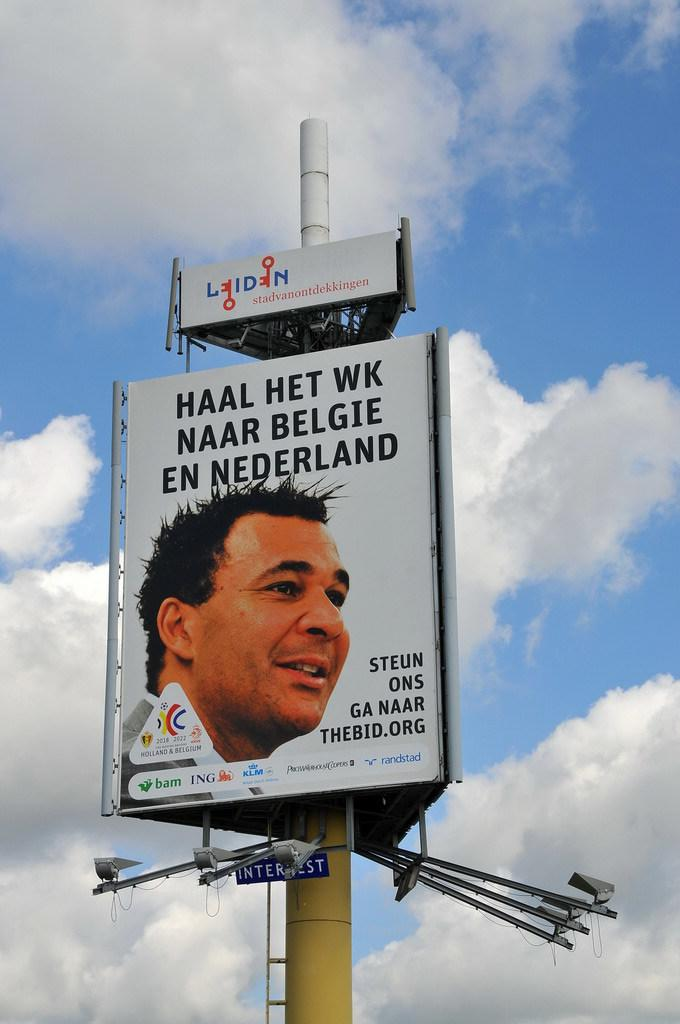<image>
Provide a brief description of the given image. A billboard that says "Haal Het WK Naar Belgie" has a man's face on it. 